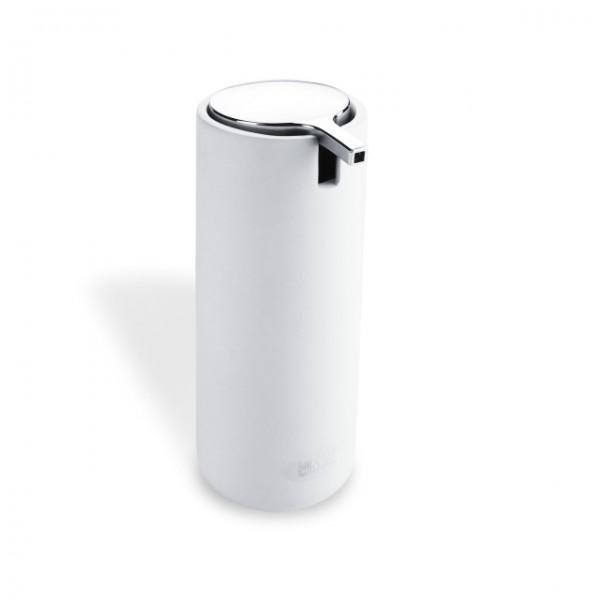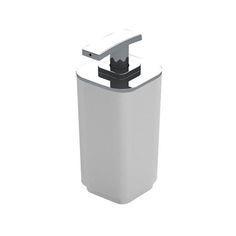The first image is the image on the left, the second image is the image on the right. Analyze the images presented: Is the assertion "The dispenser in the image on the right is round" valid? Answer yes or no. No. The first image is the image on the left, the second image is the image on the right. For the images shown, is this caption "The dispenser on the left is rectangular in shape." true? Answer yes or no. No. 